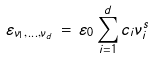Convert formula to latex. <formula><loc_0><loc_0><loc_500><loc_500>\varepsilon _ { \nu _ { 1 } , \dots , \nu _ { d } } \, = \, \varepsilon _ { 0 } \sum _ { i = 1 } ^ { d } c _ { i } \nu _ { i } ^ { s }</formula> 